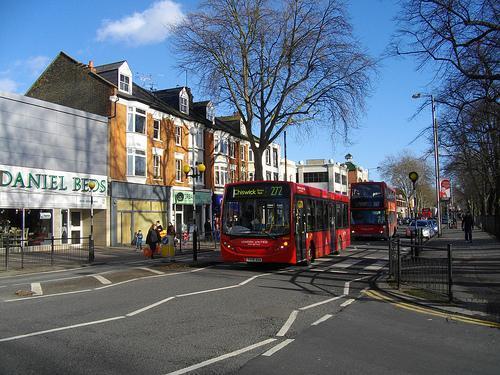How many buses do you see?
Give a very brief answer. 2. 